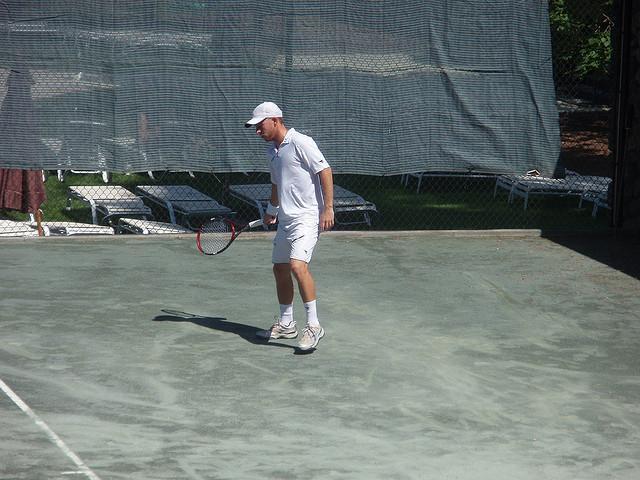How many hats are being worn backwards?
Give a very brief answer. 0. How many chairs can you see?
Give a very brief answer. 3. 